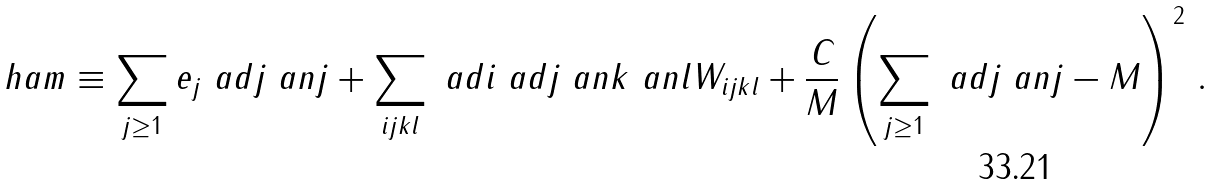Convert formula to latex. <formula><loc_0><loc_0><loc_500><loc_500>\ h a m \equiv \sum _ { j \geq 1 } e _ { j } \ a d { j } \ a n { j } + \sum _ { i j k l } \ a d { i } \ a d { j } \ a n { k } \ a n { l } W _ { i j k l } + \frac { C } { M } \left ( \sum _ { j \geq 1 } \ a d { j } \ a n { j } - M \right ) ^ { 2 } \, .</formula> 